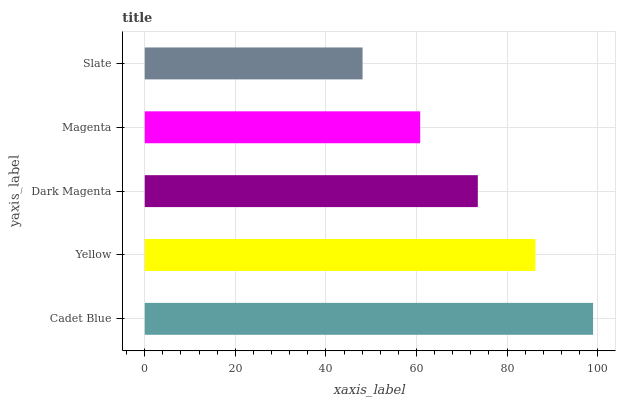Is Slate the minimum?
Answer yes or no. Yes. Is Cadet Blue the maximum?
Answer yes or no. Yes. Is Yellow the minimum?
Answer yes or no. No. Is Yellow the maximum?
Answer yes or no. No. Is Cadet Blue greater than Yellow?
Answer yes or no. Yes. Is Yellow less than Cadet Blue?
Answer yes or no. Yes. Is Yellow greater than Cadet Blue?
Answer yes or no. No. Is Cadet Blue less than Yellow?
Answer yes or no. No. Is Dark Magenta the high median?
Answer yes or no. Yes. Is Dark Magenta the low median?
Answer yes or no. Yes. Is Cadet Blue the high median?
Answer yes or no. No. Is Magenta the low median?
Answer yes or no. No. 